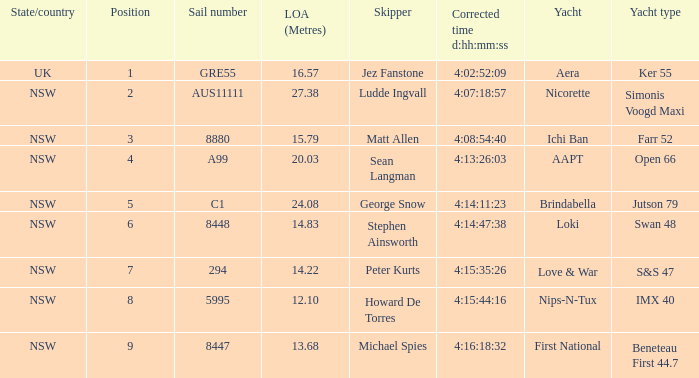Which sailing vessel had a modified time of 4:14:11:23 in the race? Brindabella. 